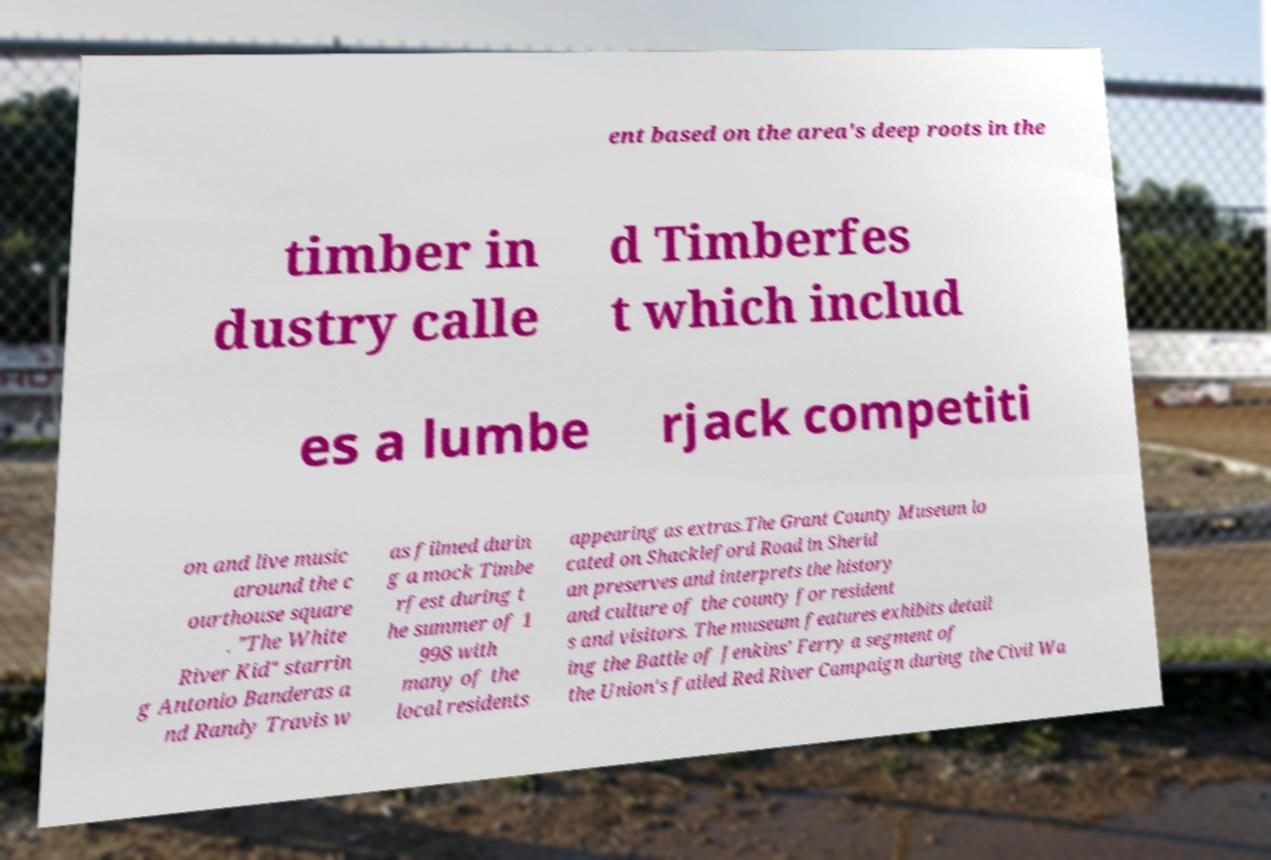There's text embedded in this image that I need extracted. Can you transcribe it verbatim? ent based on the area's deep roots in the timber in dustry calle d Timberfes t which includ es a lumbe rjack competiti on and live music around the c ourthouse square . "The White River Kid" starrin g Antonio Banderas a nd Randy Travis w as filmed durin g a mock Timbe rfest during t he summer of 1 998 with many of the local residents appearing as extras.The Grant County Museum lo cated on Shackleford Road in Sherid an preserves and interprets the history and culture of the county for resident s and visitors. The museum features exhibits detail ing the Battle of Jenkins' Ferry a segment of the Union's failed Red River Campaign during the Civil Wa 